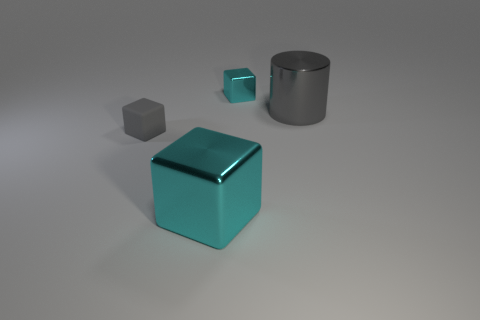Subtract all tiny cyan cubes. How many cubes are left? 2 Add 4 large green cylinders. How many objects exist? 8 Subtract all cyan cubes. How many cubes are left? 1 Subtract 3 blocks. How many blocks are left? 0 Add 4 cubes. How many cubes are left? 7 Add 4 red matte cylinders. How many red matte cylinders exist? 4 Subtract 0 yellow cylinders. How many objects are left? 4 Subtract all blocks. How many objects are left? 1 Subtract all cyan cylinders. Subtract all purple spheres. How many cylinders are left? 1 Subtract all red spheres. How many yellow cylinders are left? 0 